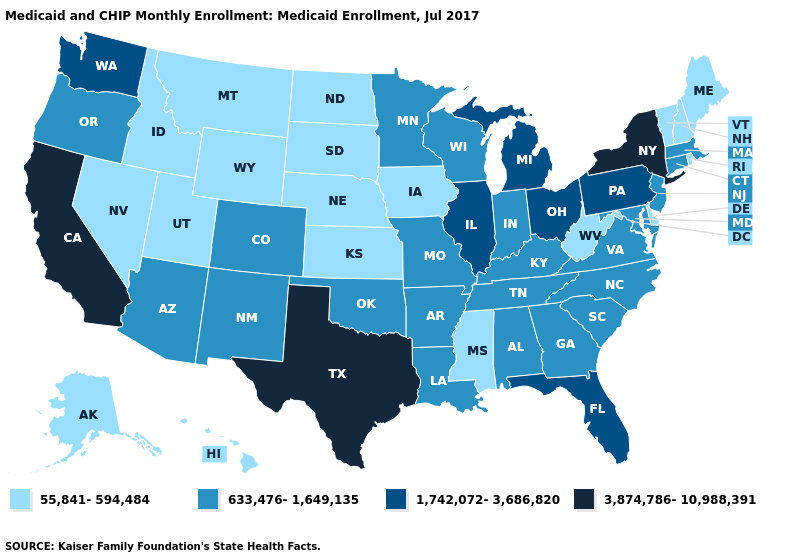Among the states that border Connecticut , does Rhode Island have the lowest value?
Short answer required. Yes. Does the first symbol in the legend represent the smallest category?
Keep it brief. Yes. Does West Virginia have a higher value than Arkansas?
Be succinct. No. Among the states that border South Carolina , which have the highest value?
Short answer required. Georgia, North Carolina. What is the value of Alabama?
Be succinct. 633,476-1,649,135. Does Tennessee have the same value as Ohio?
Keep it brief. No. Which states have the lowest value in the USA?
Be succinct. Alaska, Delaware, Hawaii, Idaho, Iowa, Kansas, Maine, Mississippi, Montana, Nebraska, Nevada, New Hampshire, North Dakota, Rhode Island, South Dakota, Utah, Vermont, West Virginia, Wyoming. What is the highest value in the USA?
Short answer required. 3,874,786-10,988,391. What is the value of Pennsylvania?
Short answer required. 1,742,072-3,686,820. What is the value of New York?
Give a very brief answer. 3,874,786-10,988,391. Name the states that have a value in the range 633,476-1,649,135?
Write a very short answer. Alabama, Arizona, Arkansas, Colorado, Connecticut, Georgia, Indiana, Kentucky, Louisiana, Maryland, Massachusetts, Minnesota, Missouri, New Jersey, New Mexico, North Carolina, Oklahoma, Oregon, South Carolina, Tennessee, Virginia, Wisconsin. Is the legend a continuous bar?
Write a very short answer. No. Does Kansas have the same value as Iowa?
Answer briefly. Yes. Does Mississippi have a lower value than Indiana?
Give a very brief answer. Yes. 